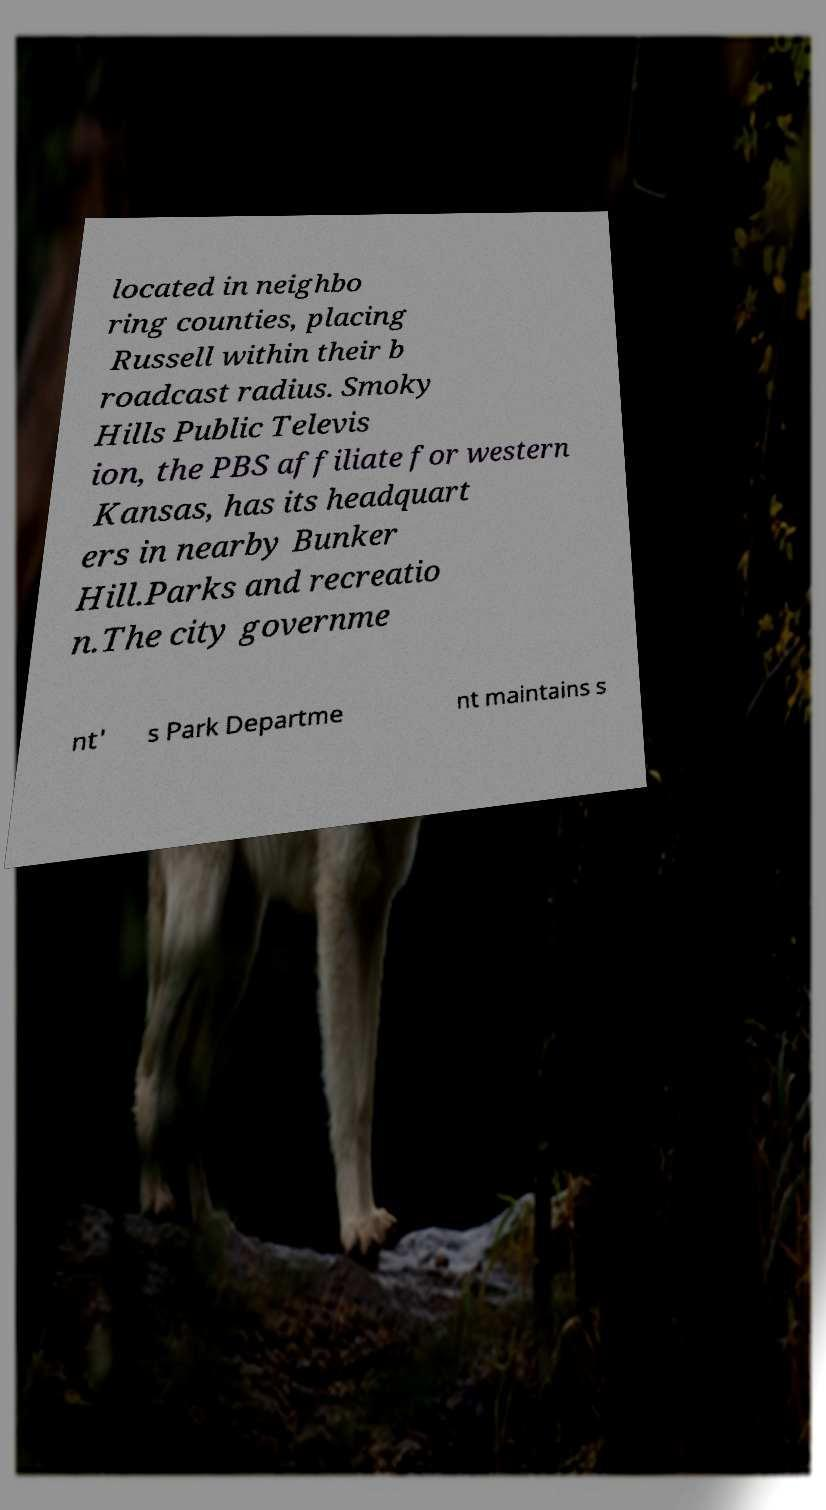Can you accurately transcribe the text from the provided image for me? located in neighbo ring counties, placing Russell within their b roadcast radius. Smoky Hills Public Televis ion, the PBS affiliate for western Kansas, has its headquart ers in nearby Bunker Hill.Parks and recreatio n.The city governme nt' s Park Departme nt maintains s 